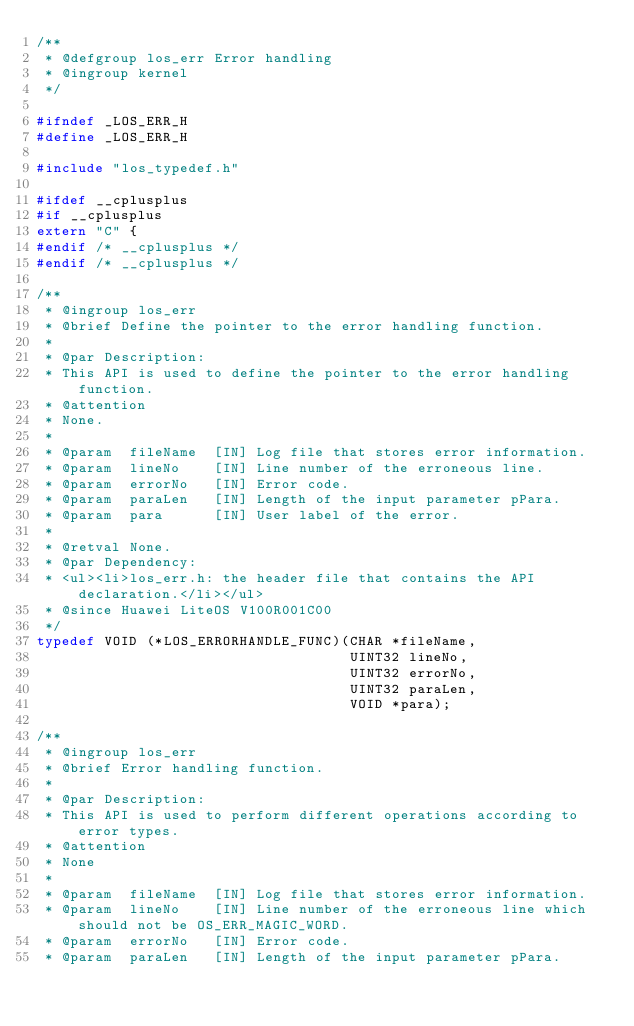<code> <loc_0><loc_0><loc_500><loc_500><_C_>/**
 * @defgroup los_err Error handling
 * @ingroup kernel
 */

#ifndef _LOS_ERR_H
#define _LOS_ERR_H

#include "los_typedef.h"

#ifdef __cplusplus
#if __cplusplus
extern "C" {
#endif /* __cplusplus */
#endif /* __cplusplus */

/**
 * @ingroup los_err
 * @brief Define the pointer to the error handling function.
 *
 * @par Description:
 * This API is used to define the pointer to the error handling function.
 * @attention
 * None.
 *
 * @param  fileName  [IN] Log file that stores error information.
 * @param  lineNo    [IN] Line number of the erroneous line.
 * @param  errorNo   [IN] Error code.
 * @param  paraLen   [IN] Length of the input parameter pPara.
 * @param  para      [IN] User label of the error.
 *
 * @retval None.
 * @par Dependency:
 * <ul><li>los_err.h: the header file that contains the API declaration.</li></ul>
 * @since Huawei LiteOS V100R001C00
 */
typedef VOID (*LOS_ERRORHANDLE_FUNC)(CHAR *fileName,
                                     UINT32 lineNo,
                                     UINT32 errorNo,
                                     UINT32 paraLen,
                                     VOID *para);

/**
 * @ingroup los_err
 * @brief Error handling function.
 *
 * @par Description:
 * This API is used to perform different operations according to error types.
 * @attention
 * None
 *
 * @param  fileName  [IN] Log file that stores error information.
 * @param  lineNo    [IN] Line number of the erroneous line which should not be OS_ERR_MAGIC_WORD.
 * @param  errorNo   [IN] Error code.
 * @param  paraLen   [IN] Length of the input parameter pPara.</code> 